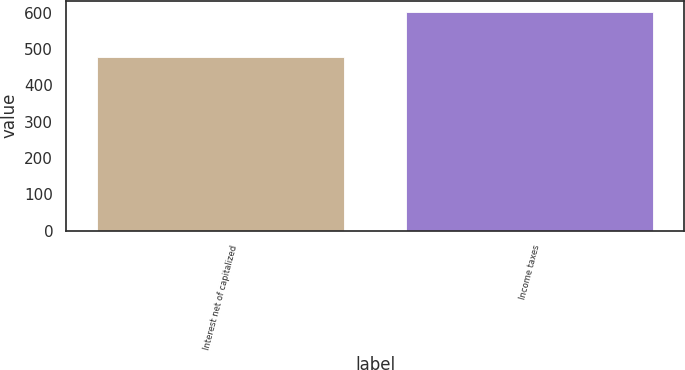Convert chart. <chart><loc_0><loc_0><loc_500><loc_500><bar_chart><fcel>Interest net of capitalized<fcel>Income taxes<nl><fcel>478<fcel>603<nl></chart> 